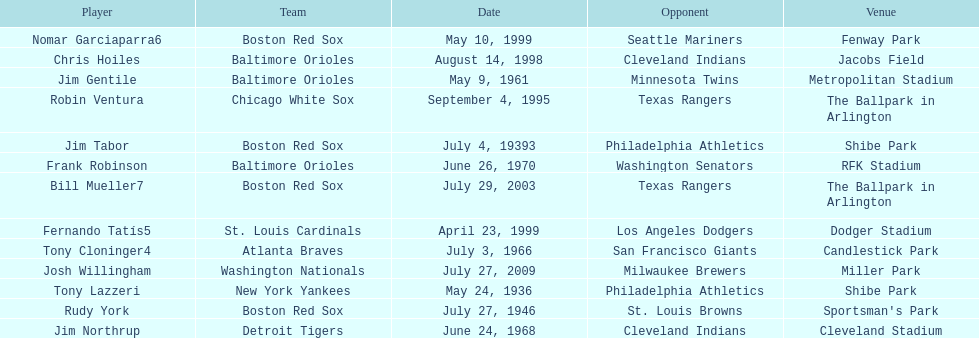Who was the opponent for the boston red sox on july 27, 1946? St. Louis Browns. 